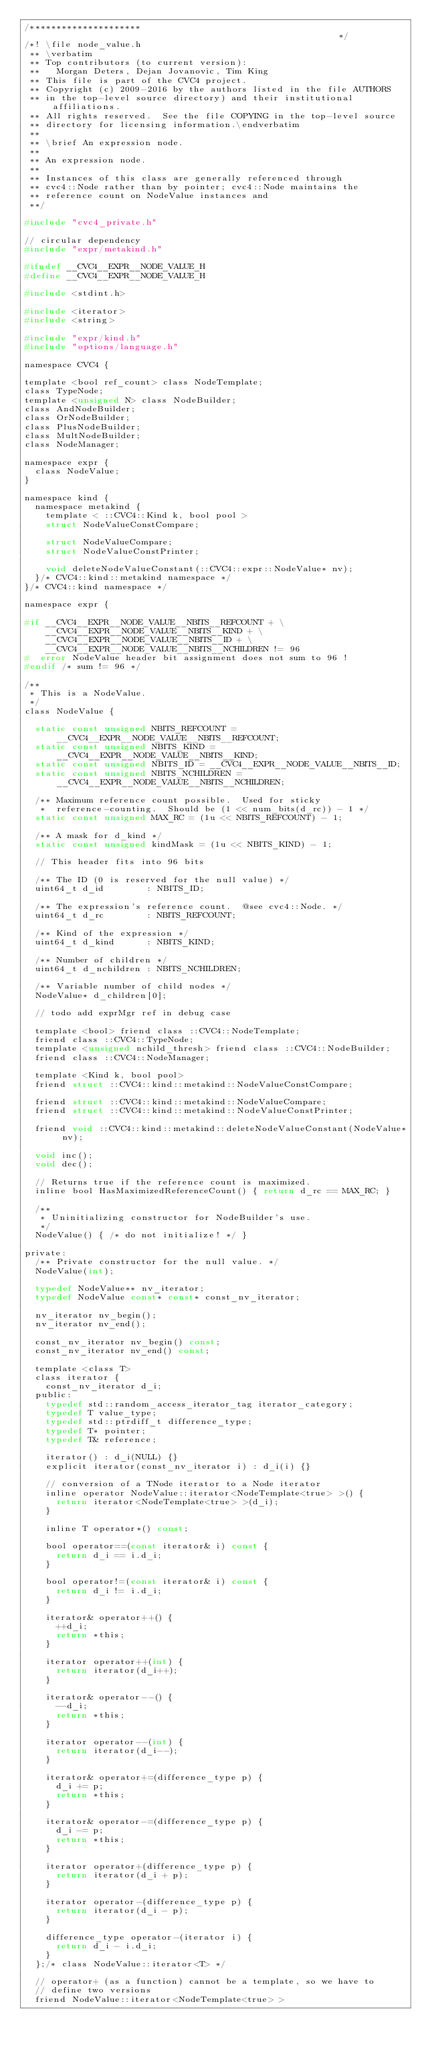<code> <loc_0><loc_0><loc_500><loc_500><_C_>/*********************                                                        */
/*! \file node_value.h
 ** \verbatim
 ** Top contributors (to current version):
 **   Morgan Deters, Dejan Jovanovic, Tim King
 ** This file is part of the CVC4 project.
 ** Copyright (c) 2009-2016 by the authors listed in the file AUTHORS
 ** in the top-level source directory) and their institutional affiliations.
 ** All rights reserved.  See the file COPYING in the top-level source
 ** directory for licensing information.\endverbatim
 **
 ** \brief An expression node.
 **
 ** An expression node.
 **
 ** Instances of this class are generally referenced through
 ** cvc4::Node rather than by pointer; cvc4::Node maintains the
 ** reference count on NodeValue instances and
 **/

#include "cvc4_private.h"

// circular dependency
#include "expr/metakind.h"

#ifndef __CVC4__EXPR__NODE_VALUE_H
#define __CVC4__EXPR__NODE_VALUE_H

#include <stdint.h>

#include <iterator>
#include <string>

#include "expr/kind.h"
#include "options/language.h"

namespace CVC4 {

template <bool ref_count> class NodeTemplate;
class TypeNode;
template <unsigned N> class NodeBuilder;
class AndNodeBuilder;
class OrNodeBuilder;
class PlusNodeBuilder;
class MultNodeBuilder;
class NodeManager;

namespace expr {
  class NodeValue;
}

namespace kind {
  namespace metakind {
    template < ::CVC4::Kind k, bool pool >
    struct NodeValueConstCompare;

    struct NodeValueCompare;
    struct NodeValueConstPrinter;

    void deleteNodeValueConstant(::CVC4::expr::NodeValue* nv);
  }/* CVC4::kind::metakind namespace */
}/* CVC4::kind namespace */

namespace expr {

#if __CVC4__EXPR__NODE_VALUE__NBITS__REFCOUNT + \
    __CVC4__EXPR__NODE_VALUE__NBITS__KIND + \
    __CVC4__EXPR__NODE_VALUE__NBITS__ID + \
    __CVC4__EXPR__NODE_VALUE__NBITS__NCHILDREN != 96
#  error NodeValue header bit assignment does not sum to 96 !
#endif /* sum != 96 */

/**
 * This is a NodeValue.
 */
class NodeValue {

  static const unsigned NBITS_REFCOUNT = __CVC4__EXPR__NODE_VALUE__NBITS__REFCOUNT;
  static const unsigned NBITS_KIND = __CVC4__EXPR__NODE_VALUE__NBITS__KIND;
  static const unsigned NBITS_ID = __CVC4__EXPR__NODE_VALUE__NBITS__ID;
  static const unsigned NBITS_NCHILDREN = __CVC4__EXPR__NODE_VALUE__NBITS__NCHILDREN;

  /** Maximum reference count possible.  Used for sticky
   *  reference-counting.  Should be (1 << num_bits(d_rc)) - 1 */
  static const unsigned MAX_RC = (1u << NBITS_REFCOUNT) - 1;

  /** A mask for d_kind */
  static const unsigned kindMask = (1u << NBITS_KIND) - 1;

  // This header fits into 96 bits

  /** The ID (0 is reserved for the null value) */
  uint64_t d_id        : NBITS_ID;

  /** The expression's reference count.  @see cvc4::Node. */
  uint64_t d_rc        : NBITS_REFCOUNT;

  /** Kind of the expression */
  uint64_t d_kind      : NBITS_KIND;

  /** Number of children */
  uint64_t d_nchildren : NBITS_NCHILDREN;

  /** Variable number of child nodes */
  NodeValue* d_children[0];

  // todo add exprMgr ref in debug case

  template <bool> friend class ::CVC4::NodeTemplate;
  friend class ::CVC4::TypeNode;
  template <unsigned nchild_thresh> friend class ::CVC4::NodeBuilder;
  friend class ::CVC4::NodeManager;

  template <Kind k, bool pool>
  friend struct ::CVC4::kind::metakind::NodeValueConstCompare;

  friend struct ::CVC4::kind::metakind::NodeValueCompare;
  friend struct ::CVC4::kind::metakind::NodeValueConstPrinter;

  friend void ::CVC4::kind::metakind::deleteNodeValueConstant(NodeValue* nv);

  void inc();
  void dec();

  // Returns true if the reference count is maximized.
  inline bool HasMaximizedReferenceCount() { return d_rc == MAX_RC; }

  /**
   * Uninitializing constructor for NodeBuilder's use.
   */
  NodeValue() { /* do not initialize! */ }

private:
  /** Private constructor for the null value. */
  NodeValue(int);

  typedef NodeValue** nv_iterator;
  typedef NodeValue const* const* const_nv_iterator;

  nv_iterator nv_begin();
  nv_iterator nv_end();

  const_nv_iterator nv_begin() const;
  const_nv_iterator nv_end() const;

  template <class T>
  class iterator {
    const_nv_iterator d_i;
  public:
    typedef std::random_access_iterator_tag iterator_category;
    typedef T value_type;
    typedef std::ptrdiff_t difference_type;
    typedef T* pointer;
    typedef T& reference;

    iterator() : d_i(NULL) {}
    explicit iterator(const_nv_iterator i) : d_i(i) {}

    // conversion of a TNode iterator to a Node iterator
    inline operator NodeValue::iterator<NodeTemplate<true> >() {
      return iterator<NodeTemplate<true> >(d_i);
    }

    inline T operator*() const;

    bool operator==(const iterator& i) const {
      return d_i == i.d_i;
    }

    bool operator!=(const iterator& i) const {
      return d_i != i.d_i;
    }

    iterator& operator++() {
      ++d_i;
      return *this;
    }

    iterator operator++(int) {
      return iterator(d_i++);
    }

    iterator& operator--() {
      --d_i;
      return *this;
    }

    iterator operator--(int) {
      return iterator(d_i--);
    }

    iterator& operator+=(difference_type p) {
      d_i += p;
      return *this;
    }

    iterator& operator-=(difference_type p) {
      d_i -= p;
      return *this;
    }

    iterator operator+(difference_type p) {
      return iterator(d_i + p);
    }

    iterator operator-(difference_type p) {
      return iterator(d_i - p);
    }

    difference_type operator-(iterator i) {
      return d_i - i.d_i;
    }
  };/* class NodeValue::iterator<T> */

  // operator+ (as a function) cannot be a template, so we have to
  // define two versions
  friend NodeValue::iterator<NodeTemplate<true> ></code> 